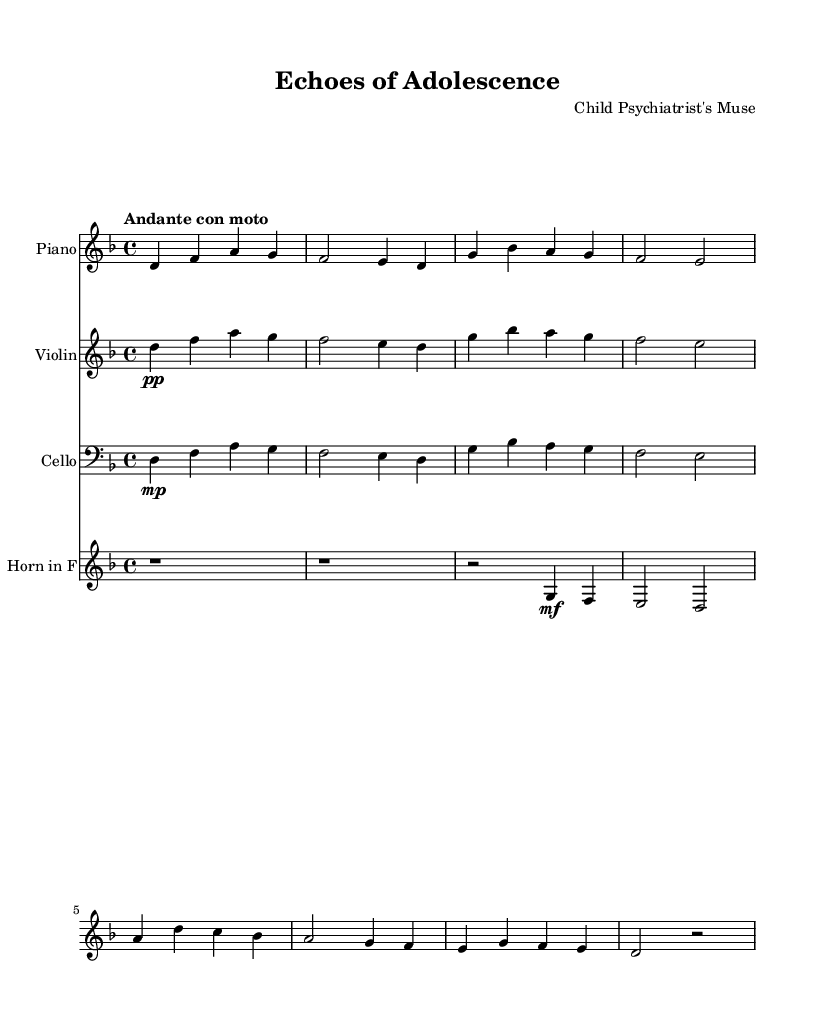What is the key signature of this music? The key signature is indicated by the sharps or flats at the beginning of the staff. In this case, there are no sharps or flats, which means it is in D minor, which has one flat.
Answer: D minor What is the time signature of this music? The time signature is found at the beginning of the music, indicating how many beats are in each measure. Here, it shows a 4 on top of a 4, meaning there are four beats in a measure.
Answer: 4/4 What is the tempo marking for this piece? The tempo marking is typically found at the beginning, indicating the speed of the music. In this case, it states "Andante con moto," which translates to a moderate walking pace with motion.
Answer: Andante con moto Which instrument has the highest pitch range? To determine this, we examine the clefs and the pitch notations for each instrument. The violin is in the treble clef and generally plays higher than the cello or piano, which indicates it has the highest pitch range.
Answer: Violin How many measures are in the main theme? Counting the number of distinct measures from the rendered sheet music gives a clear number. Upon reviewing the measures indicated, we find there are 8 measures in the main theme.
Answer: 8 What dynamic markings are indicated for the cello? By analyzing the dynamic notation under the cello staff, we see it is indicated as "mp" which stands for mezzo-piano, meaning moderately soft.
Answer: mezzo-piano Which instruments are included in this score? The score lists the instruments at the beginning of each staff. Here, we have Piano, Violin, Cello, and Horn in F. Each staff heading confirms this.
Answer: Piano, Violin, Cello, Horn in F 